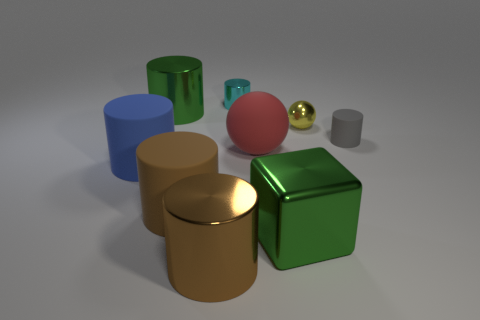Subtract all brown cylinders. How many cylinders are left? 4 Subtract all big green shiny cylinders. How many cylinders are left? 5 Subtract all purple cylinders. Subtract all blue balls. How many cylinders are left? 6 Add 1 tiny cyan metallic objects. How many objects exist? 10 Subtract all spheres. How many objects are left? 7 Subtract all purple blocks. Subtract all tiny cyan things. How many objects are left? 8 Add 1 shiny things. How many shiny things are left? 6 Add 8 blocks. How many blocks exist? 9 Subtract 0 cyan spheres. How many objects are left? 9 